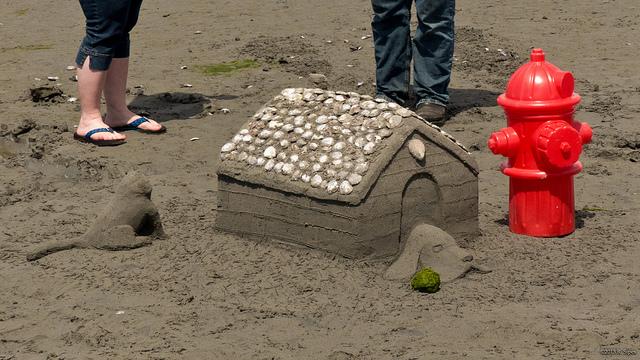What colors are the straps on the woman"s flip flops?
Short answer required. Blue. Is it a real fire hydrant?
Be succinct. No. What color is the fire hydrant?
Be succinct. Red. 